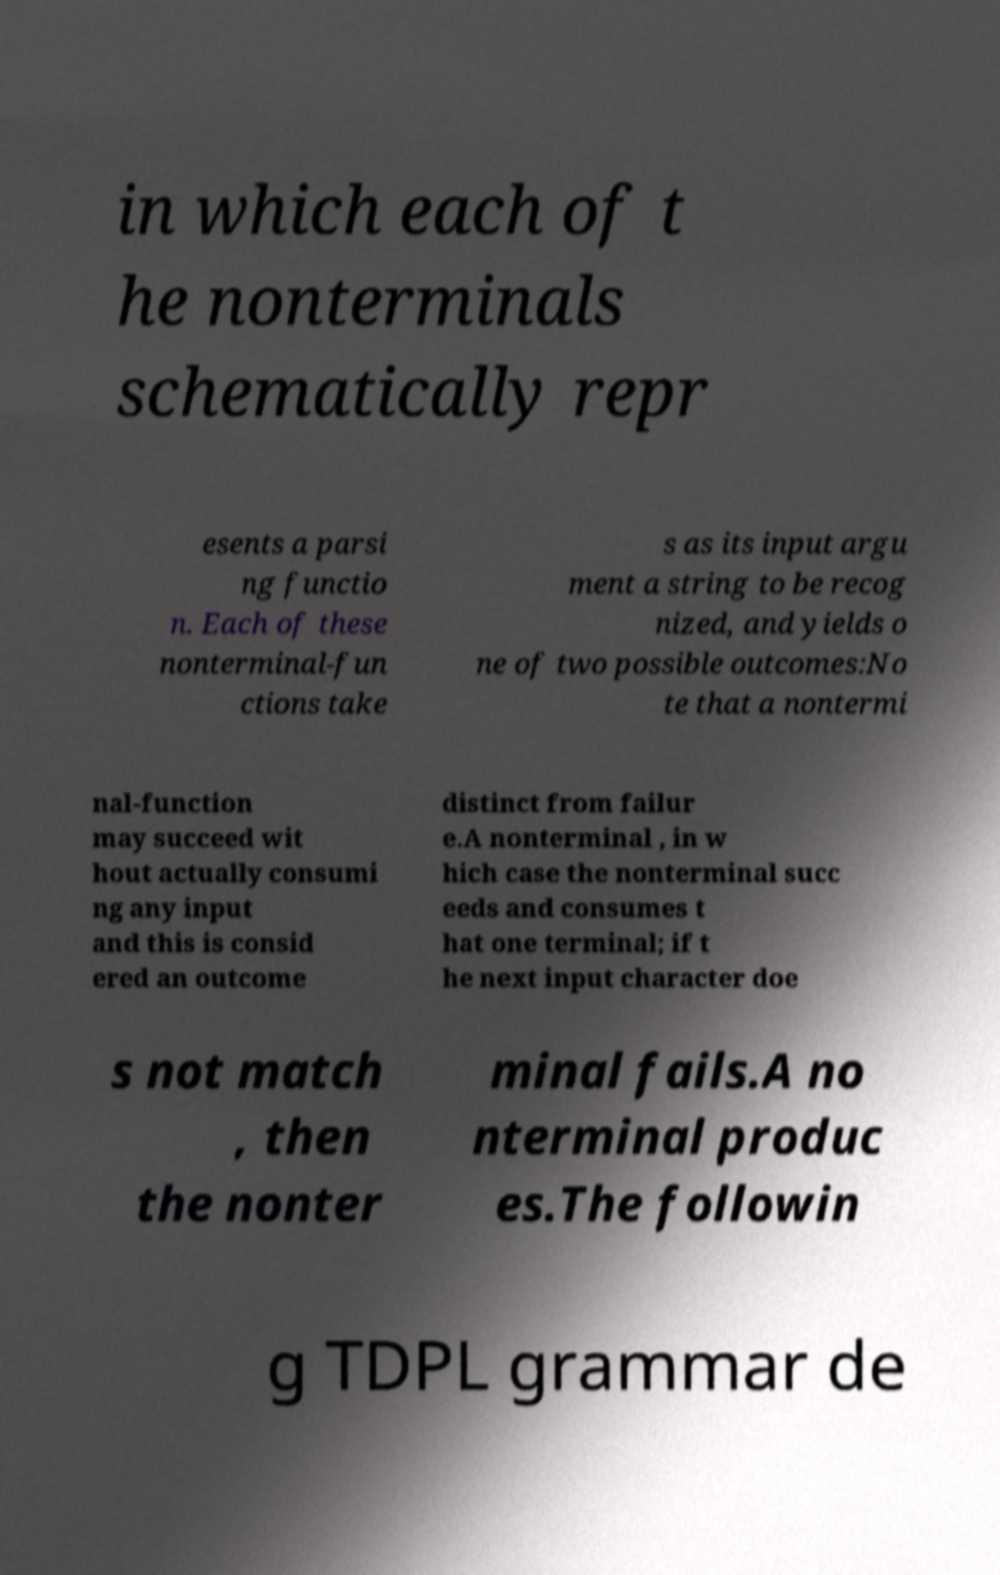I need the written content from this picture converted into text. Can you do that? in which each of t he nonterminals schematically repr esents a parsi ng functio n. Each of these nonterminal-fun ctions take s as its input argu ment a string to be recog nized, and yields o ne of two possible outcomes:No te that a nontermi nal-function may succeed wit hout actually consumi ng any input and this is consid ered an outcome distinct from failur e.A nonterminal , in w hich case the nonterminal succ eeds and consumes t hat one terminal; if t he next input character doe s not match , then the nonter minal fails.A no nterminal produc es.The followin g TDPL grammar de 